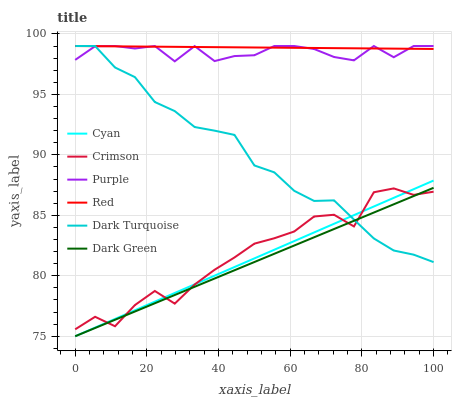Does Dark Turquoise have the minimum area under the curve?
Answer yes or no. No. Does Dark Turquoise have the maximum area under the curve?
Answer yes or no. No. Is Dark Turquoise the smoothest?
Answer yes or no. No. Is Dark Turquoise the roughest?
Answer yes or no. No. Does Dark Turquoise have the lowest value?
Answer yes or no. No. Does Crimson have the highest value?
Answer yes or no. No. Is Crimson less than Purple?
Answer yes or no. Yes. Is Purple greater than Dark Green?
Answer yes or no. Yes. Does Crimson intersect Purple?
Answer yes or no. No. 